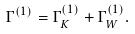<formula> <loc_0><loc_0><loc_500><loc_500>\Gamma ^ { ( 1 ) } = \Gamma ^ { ( 1 ) } _ { K } + \Gamma ^ { ( 1 ) } _ { W } .</formula> 